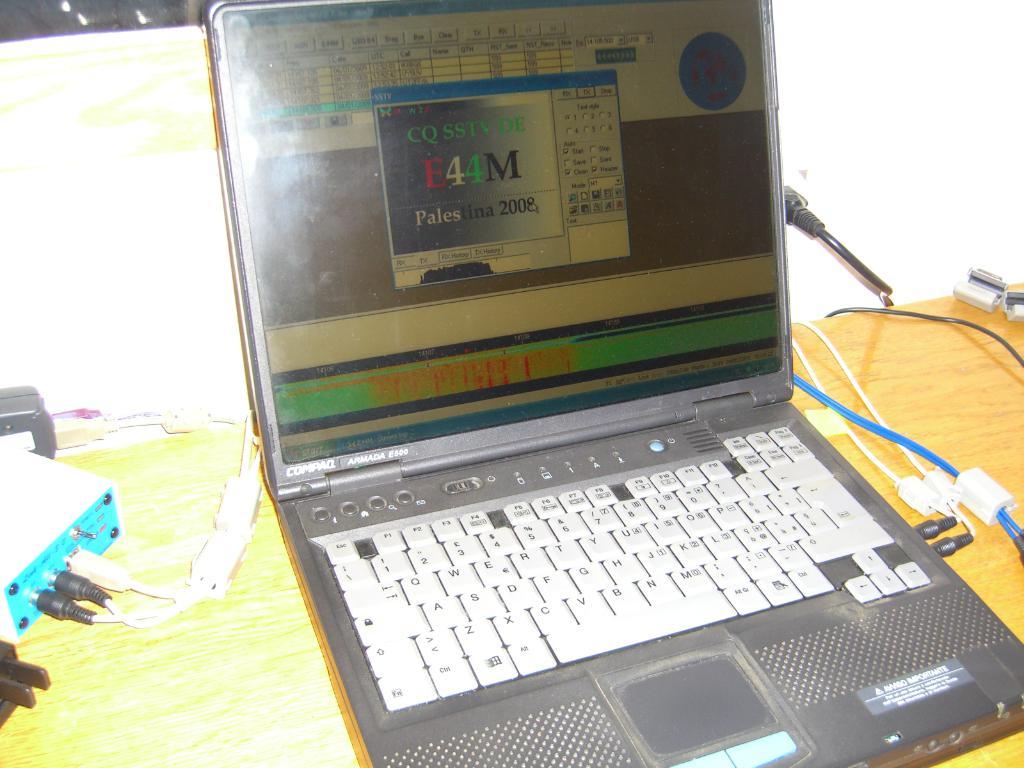What year is the software?
Provide a short and direct response. 2008. What brand is the laptop>?
Your answer should be compact. Compaq. 